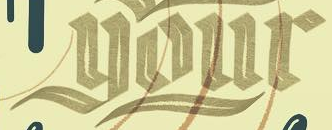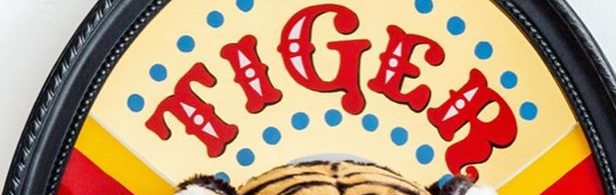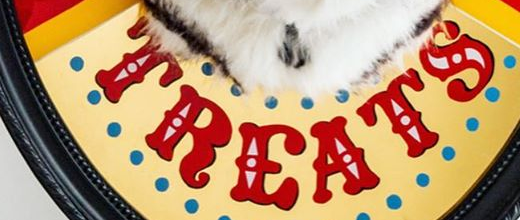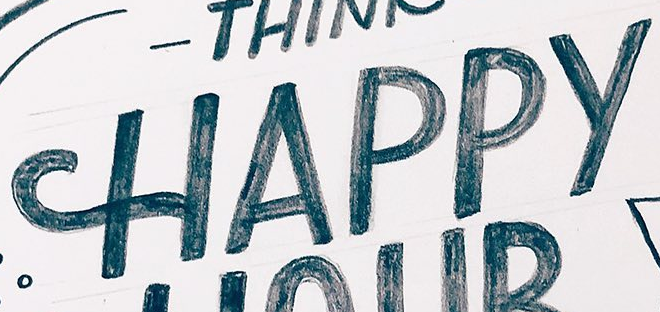What words are shown in these images in order, separated by a semicolon? your; TIGER; TREATS; HAPPY 